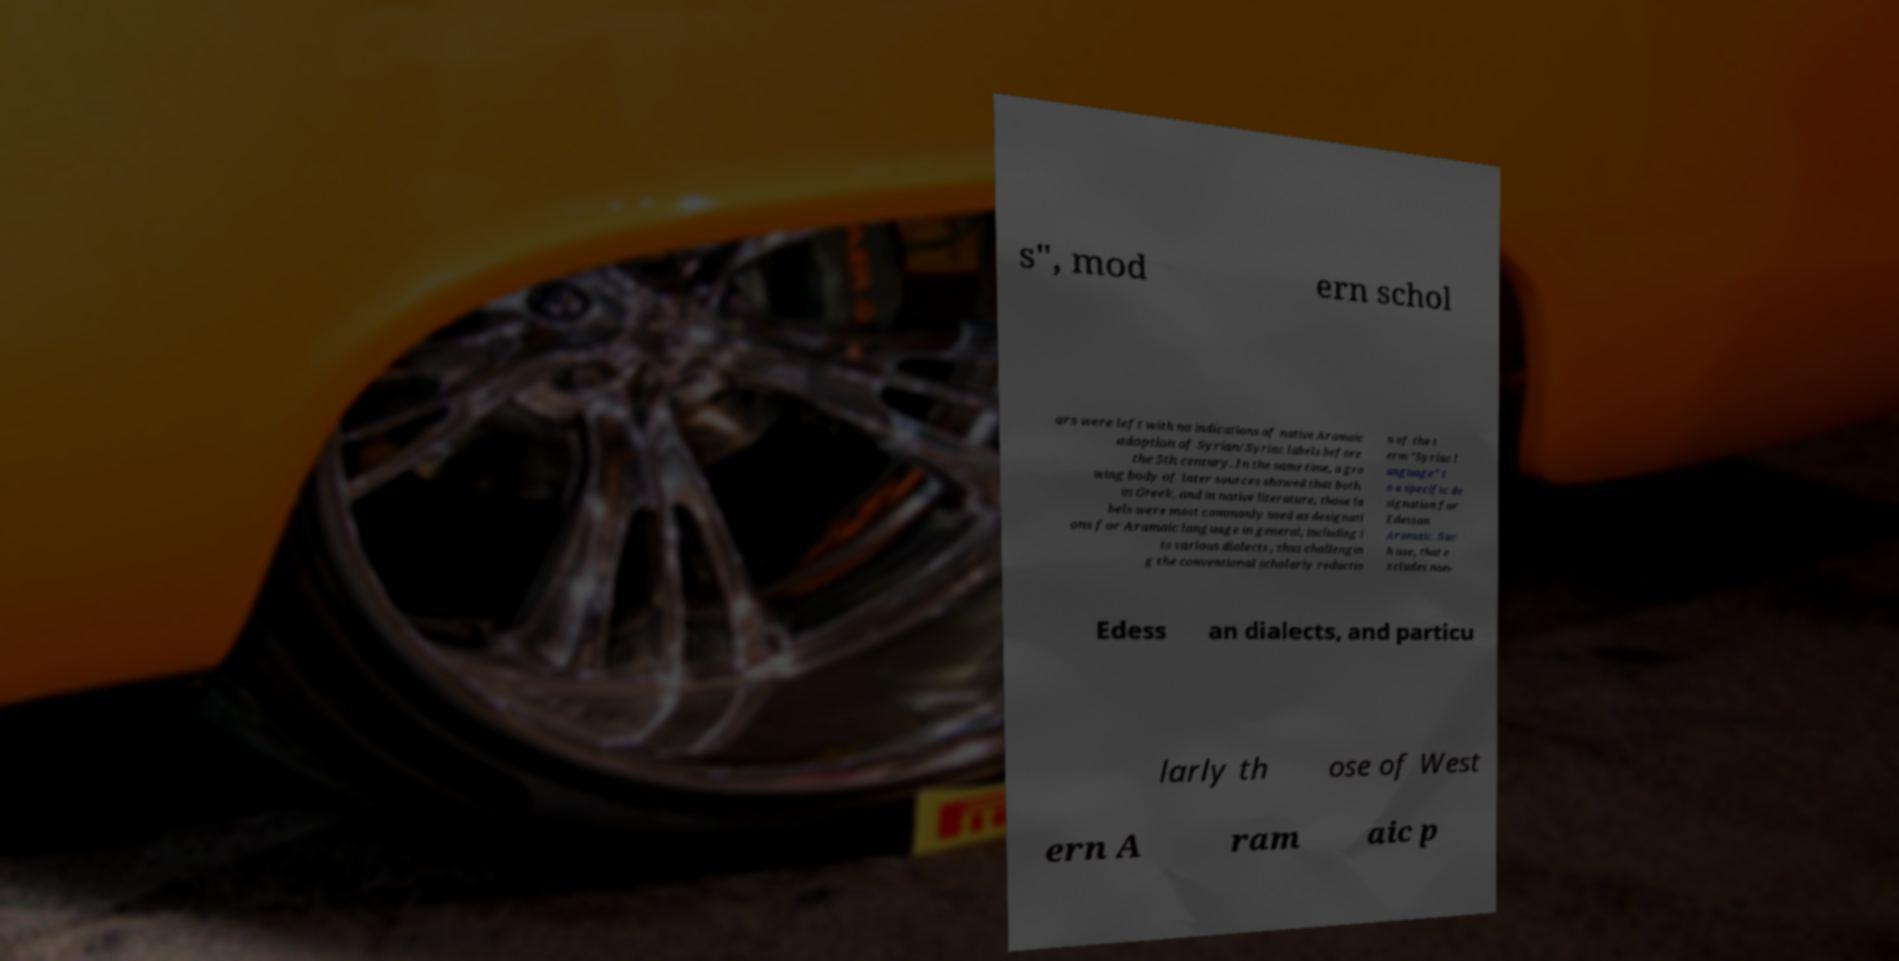I need the written content from this picture converted into text. Can you do that? s", mod ern schol ars were left with no indications of native Aramaic adoption of Syrian/Syriac labels before the 5th century. In the same time, a gro wing body of later sources showed that both in Greek, and in native literature, those la bels were most commonly used as designati ons for Aramaic language in general, including i ts various dialects , thus challengin g the conventional scholarly reductio n of the t erm "Syriac l anguage" t o a specific de signation for Edessan Aramaic. Suc h use, that e xcludes non- Edess an dialects, and particu larly th ose of West ern A ram aic p 